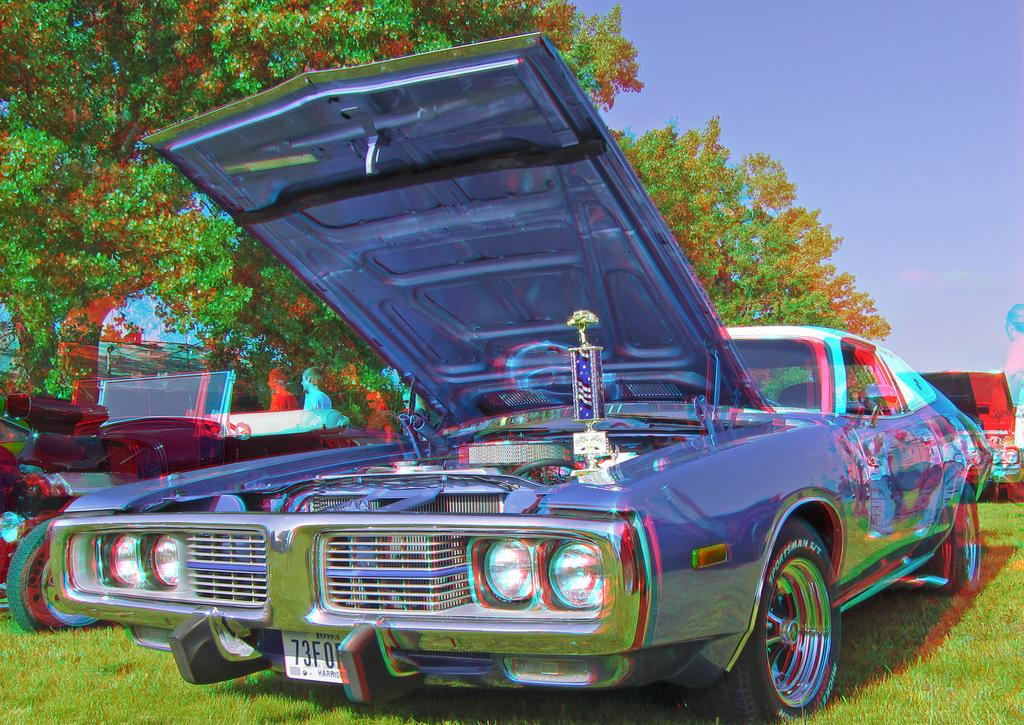What is the location of the vehicles in the image? The vehicles are parked on the grass in the image. How can the vehicles be distinguished from one another? The vehicles are in different colors. What can be seen in the background of the image? There are persons and trees in the background. What is the color of the sky in the image? The sky is blue in the image. What type of toys are the vehicles playing with in the image? There are no toys present in the image, and the vehicles are not shown to be playing with anything. 